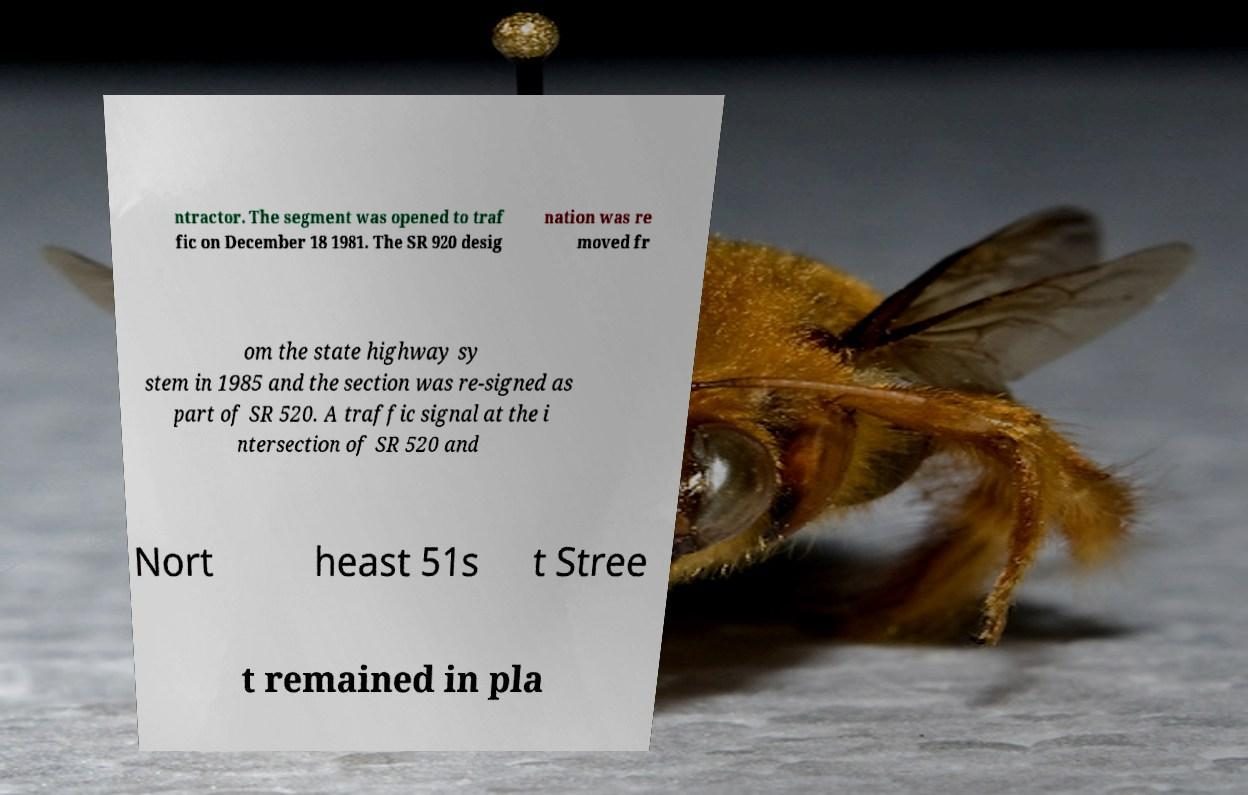For documentation purposes, I need the text within this image transcribed. Could you provide that? ntractor. The segment was opened to traf fic on December 18 1981. The SR 920 desig nation was re moved fr om the state highway sy stem in 1985 and the section was re-signed as part of SR 520. A traffic signal at the i ntersection of SR 520 and Nort heast 51s t Stree t remained in pla 